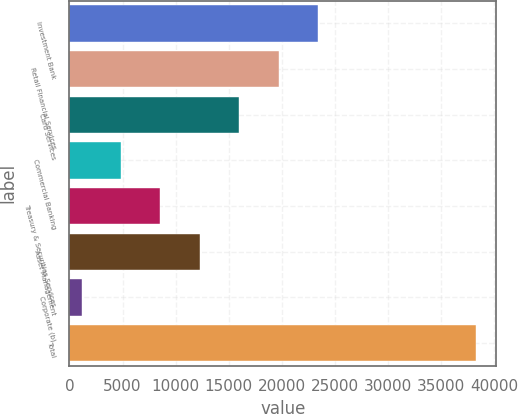Convert chart to OTSL. <chart><loc_0><loc_0><loc_500><loc_500><bar_chart><fcel>Investment Bank<fcel>Retail Financial Services<fcel>Card Services<fcel>Commercial Banking<fcel>Treasury & Securities Services<fcel>Asset Management<fcel>Corporate (b)<fcel>Total<nl><fcel>23425<fcel>19711<fcel>15997<fcel>4855<fcel>8569<fcel>12283<fcel>1141<fcel>38281<nl></chart> 